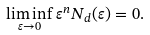<formula> <loc_0><loc_0><loc_500><loc_500>\liminf _ { \varepsilon \rightarrow 0 } \varepsilon ^ { n } N _ { d } ( \varepsilon ) = 0 .</formula> 